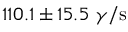Convert formula to latex. <formula><loc_0><loc_0><loc_500><loc_500>1 1 0 . 1 \pm 1 5 . 5 \gamma / s</formula> 